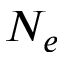Convert formula to latex. <formula><loc_0><loc_0><loc_500><loc_500>N _ { e }</formula> 